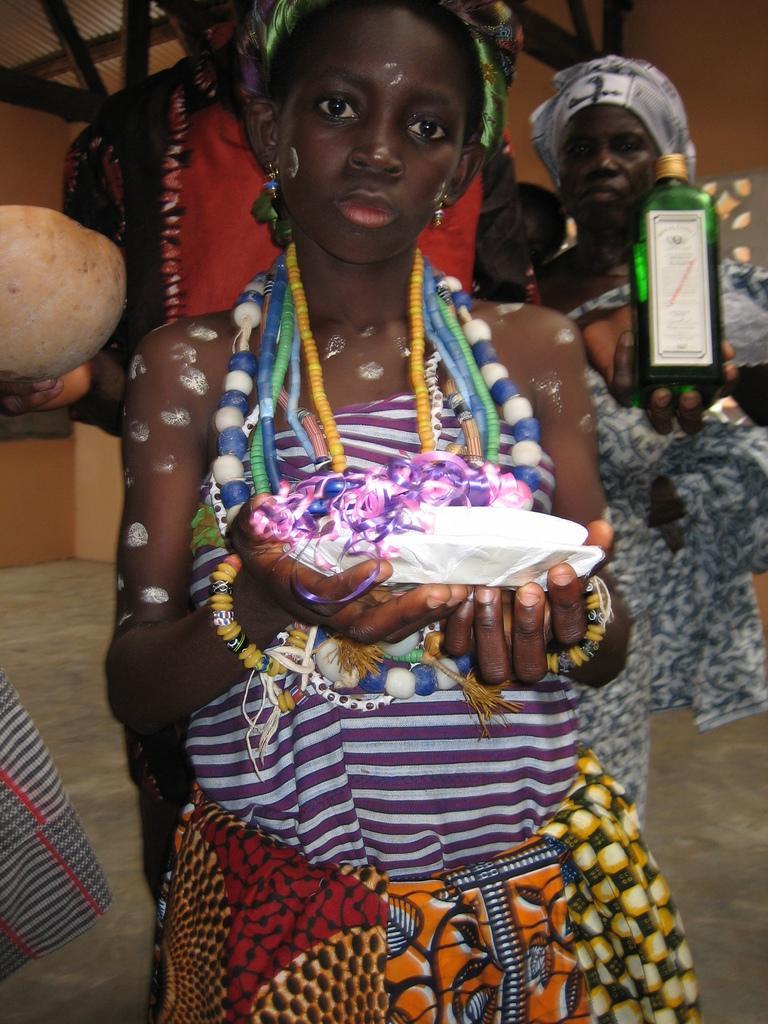Please provide a concise description of this image. In this image we can see a group of people wearing dress are standing. Some persons are holding objects in their hands. In the background, we can see wood pieces, wall and the roof. 